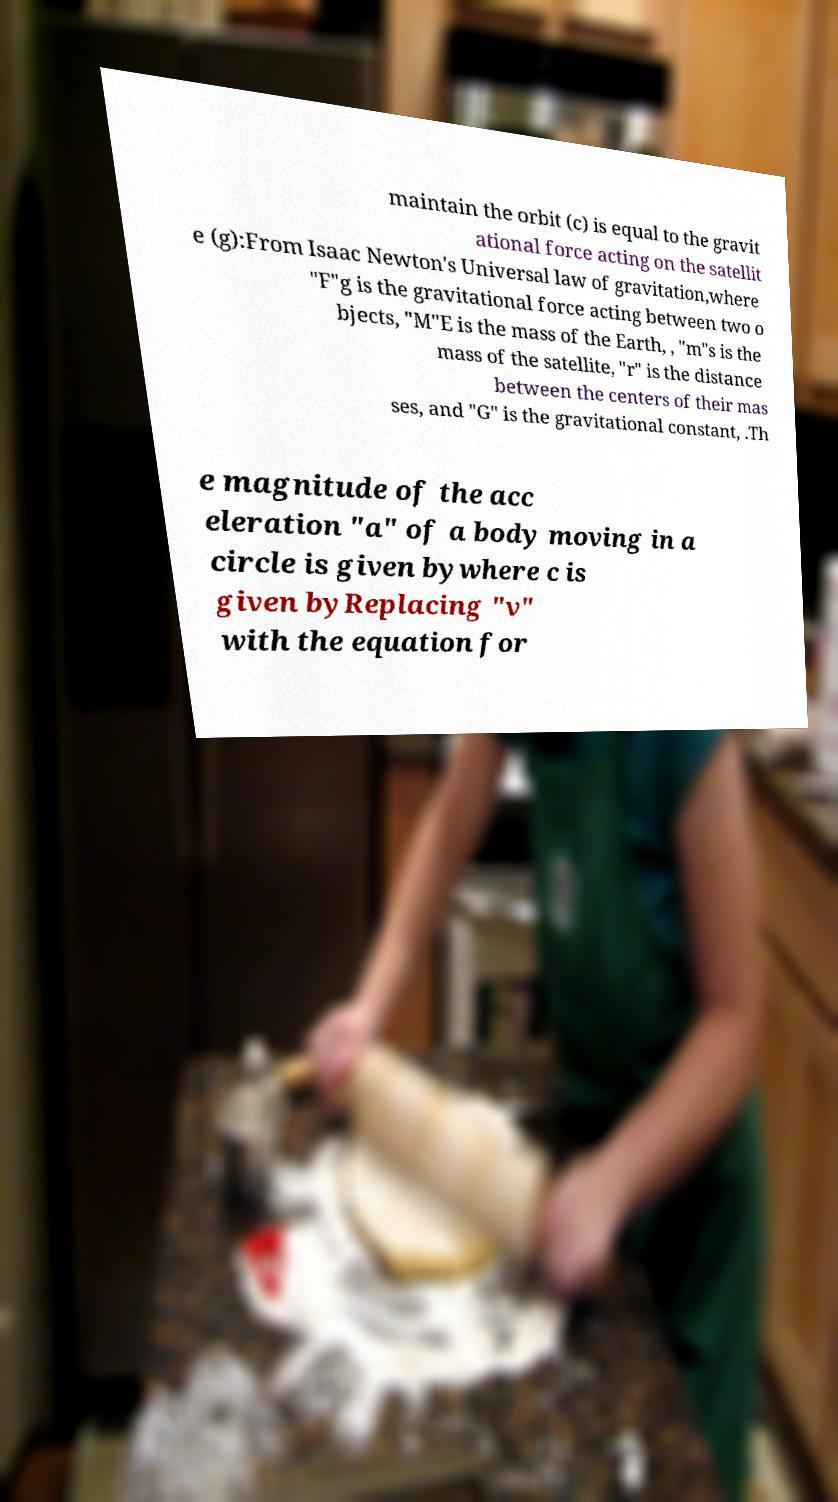Please read and relay the text visible in this image. What does it say? maintain the orbit (c) is equal to the gravit ational force acting on the satellit e (g):From Isaac Newton's Universal law of gravitation,where "F"g is the gravitational force acting between two o bjects, "M"E is the mass of the Earth, , "m"s is the mass of the satellite, "r" is the distance between the centers of their mas ses, and "G" is the gravitational constant, .Th e magnitude of the acc eleration "a" of a body moving in a circle is given bywhere c is given byReplacing "v" with the equation for 